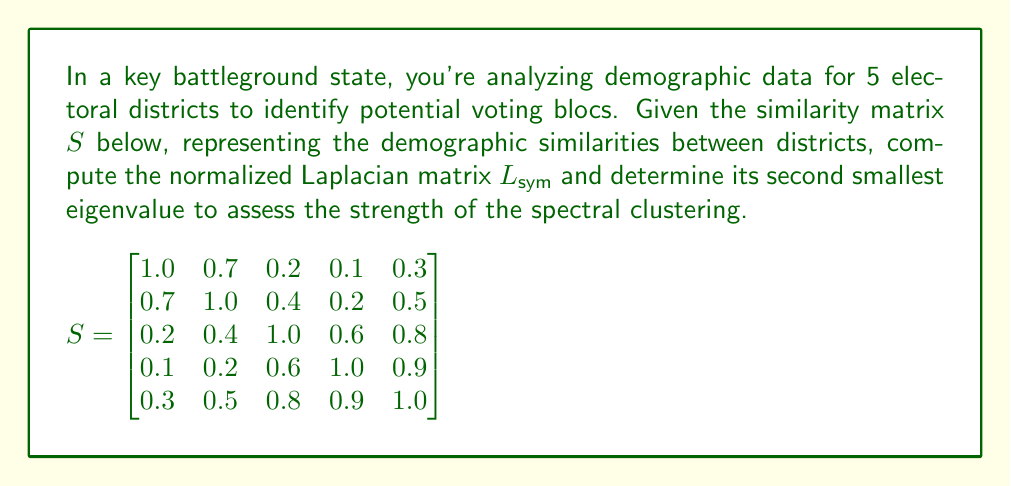Provide a solution to this math problem. To solve this problem, we'll follow these steps:

1) First, calculate the degree matrix $D$:
   $$D = \text{diag}(2.3, 2.8, 3.0, 2.8, 3.5)$$

2) Compute the graph Laplacian $L = D - S$:
   $$L = \begin{bmatrix}
   1.3 & -0.7 & -0.2 & -0.1 & -0.3 \\
   -0.7 & 1.8 & -0.4 & -0.2 & -0.5 \\
   -0.2 & -0.4 & 2.0 & -0.6 & -0.8 \\
   -0.1 & -0.2 & -0.6 & 1.8 & -0.9 \\
   -0.3 & -0.5 & -0.8 & -0.9 & 2.5
   \end{bmatrix}$$

3) Calculate $D^{-1/2}$:
   $$D^{-1/2} = \text{diag}(1/\sqrt{2.3}, 1/\sqrt{2.8}, 1/\sqrt{3.0}, 1/\sqrt{2.8}, 1/\sqrt{3.5})$$

4) Compute the normalized Laplacian $L_{\text{sym}} = D^{-1/2}LD^{-1/2}$:
   $$L_{\text{sym}} \approx \begin{bmatrix}
   1.0000 & -0.4881 & -0.1348 & -0.0697 & -0.1867 \\
   -0.4881 & 1.0000 & -0.2148 & -0.1111 & -0.2478 \\
   -0.1348 & -0.2148 & 1.0000 & -0.3086 & -0.3697 \\
   -0.0697 & -0.1111 & -0.3086 & 1.0000 & -0.4459 \\
   -0.1867 & -0.2478 & -0.3697 & -0.4459 & 1.0000
   \end{bmatrix}$$

5) Calculate the eigenvalues of $L_{\text{sym}}$:
   $$\lambda_1 \approx 0.0000, \lambda_2 \approx 0.2838, \lambda_3 \approx 0.5858, \lambda_4 \approx 1.1304, \lambda_5 \approx 2.0000$$

The second smallest eigenvalue, $\lambda_2 \approx 0.2838$, known as the algebraic connectivity, indicates the strength of the clustering. A smaller value suggests a stronger division into clusters.
Answer: $\lambda_2 \approx 0.2838$ 